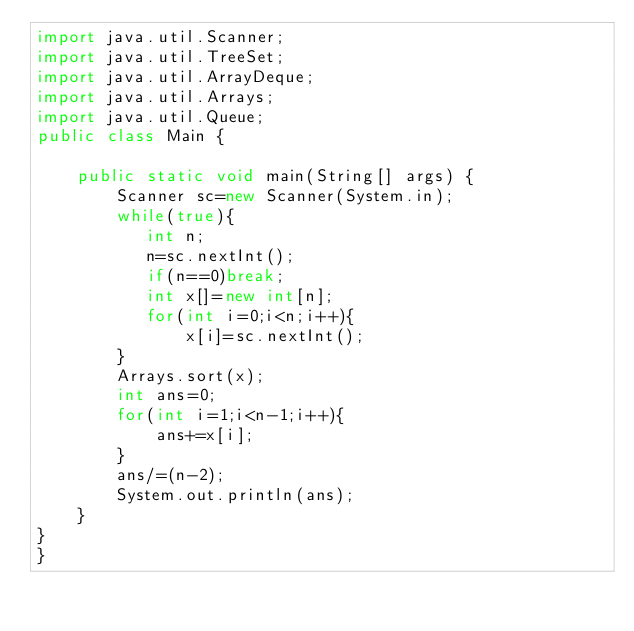Convert code to text. <code><loc_0><loc_0><loc_500><loc_500><_Java_>import java.util.Scanner;
import java.util.TreeSet;
import java.util.ArrayDeque;
import java.util.Arrays;
import java.util.Queue;
public class Main {

    public static void main(String[] args) {
        Scanner sc=new Scanner(System.in);
        while(true){
           int n;
           n=sc.nextInt();
           if(n==0)break;
           int x[]=new int[n];
           for(int i=0;i<n;i++){
               x[i]=sc.nextInt();
        }
        Arrays.sort(x);
        int ans=0;
        for(int i=1;i<n-1;i++){
            ans+=x[i];
        }
        ans/=(n-2);
        System.out.println(ans);
    }
}
}

</code> 